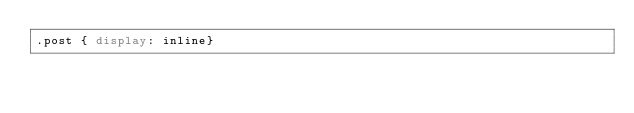Convert code to text. <code><loc_0><loc_0><loc_500><loc_500><_CSS_>.post { display: inline}
</code> 